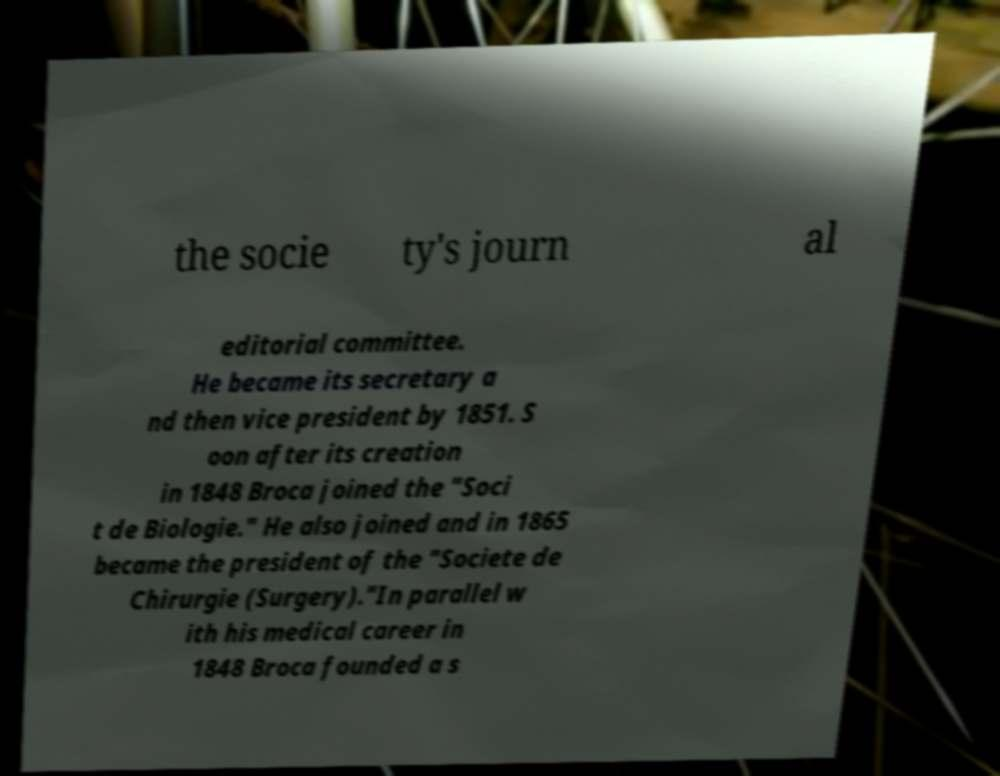Could you extract and type out the text from this image? the socie ty's journ al editorial committee. He became its secretary a nd then vice president by 1851. S oon after its creation in 1848 Broca joined the "Soci t de Biologie." He also joined and in 1865 became the president of the "Societe de Chirurgie (Surgery)."In parallel w ith his medical career in 1848 Broca founded a s 